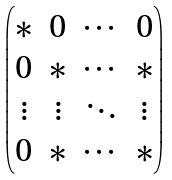Convert formula to latex. <formula><loc_0><loc_0><loc_500><loc_500>\begin{pmatrix} * & 0 & \cdots & 0 \\ 0 & * & \cdots & * \\ \vdots & \vdots & \ddots & \vdots \\ 0 & * & \cdots & * \end{pmatrix}</formula> 